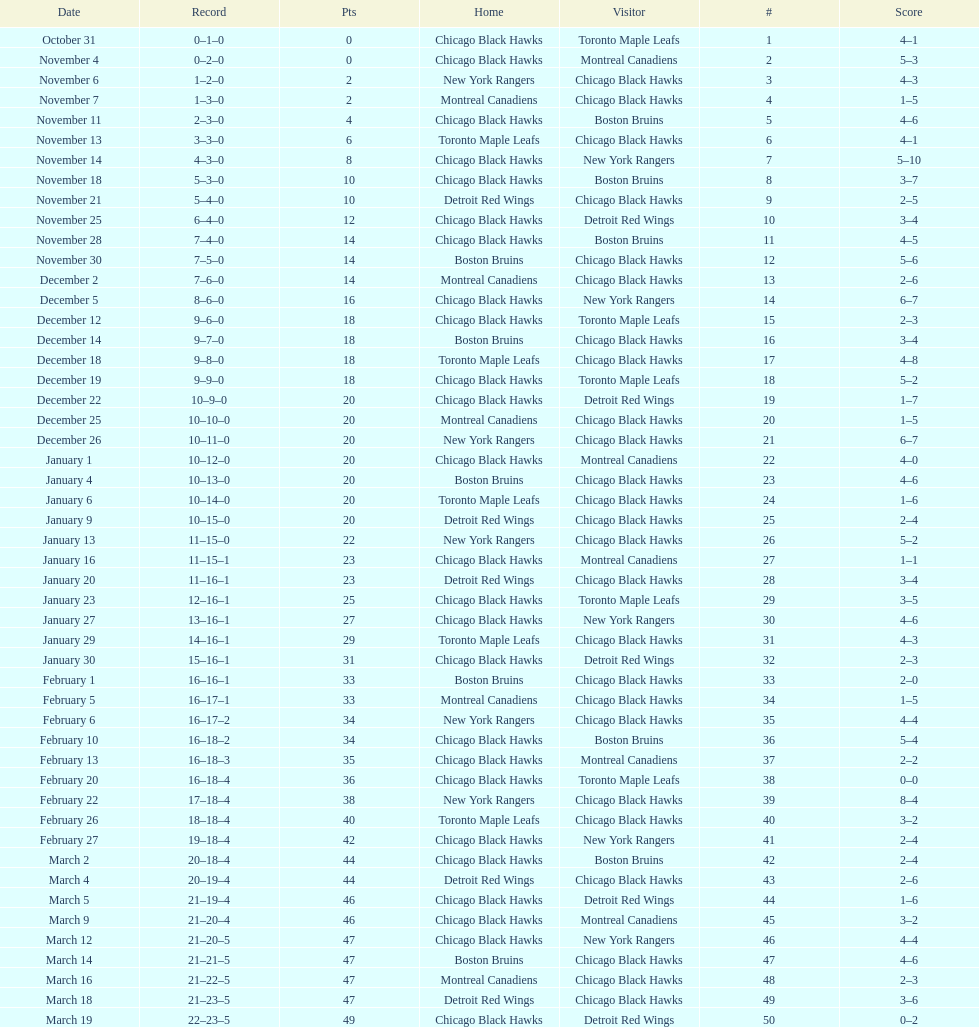What is was the difference in score in the december 19th win? 3. 